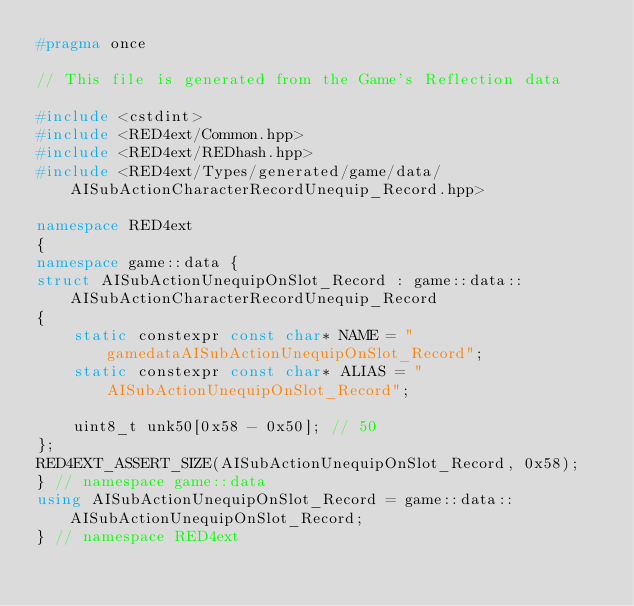<code> <loc_0><loc_0><loc_500><loc_500><_C++_>#pragma once

// This file is generated from the Game's Reflection data

#include <cstdint>
#include <RED4ext/Common.hpp>
#include <RED4ext/REDhash.hpp>
#include <RED4ext/Types/generated/game/data/AISubActionCharacterRecordUnequip_Record.hpp>

namespace RED4ext
{
namespace game::data { 
struct AISubActionUnequipOnSlot_Record : game::data::AISubActionCharacterRecordUnequip_Record
{
    static constexpr const char* NAME = "gamedataAISubActionUnequipOnSlot_Record";
    static constexpr const char* ALIAS = "AISubActionUnequipOnSlot_Record";

    uint8_t unk50[0x58 - 0x50]; // 50
};
RED4EXT_ASSERT_SIZE(AISubActionUnequipOnSlot_Record, 0x58);
} // namespace game::data
using AISubActionUnequipOnSlot_Record = game::data::AISubActionUnequipOnSlot_Record;
} // namespace RED4ext
</code> 